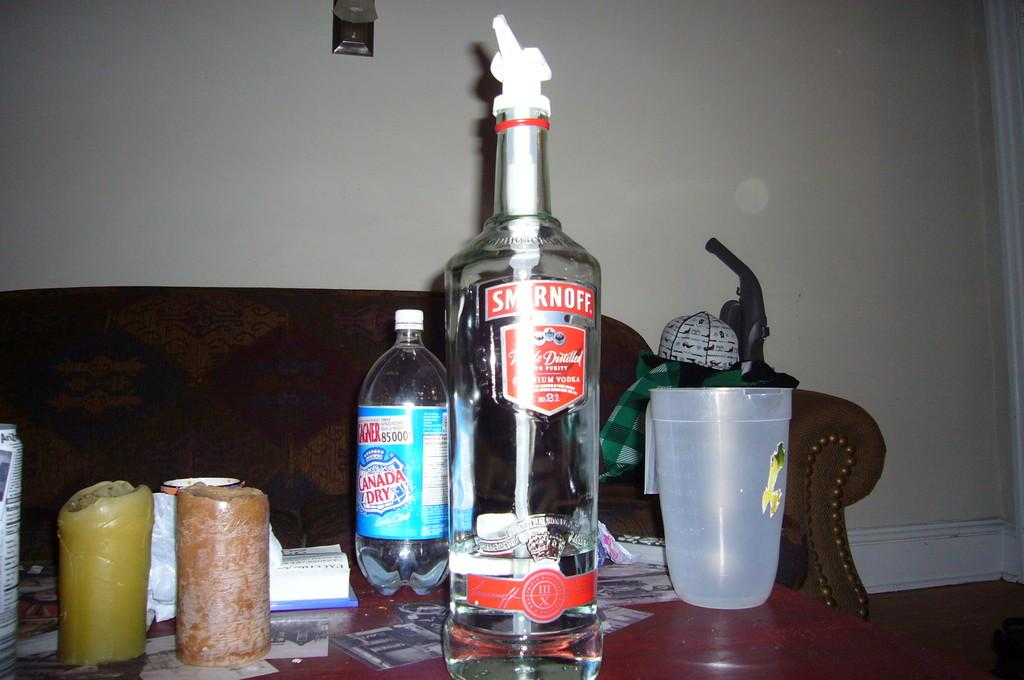<image>
Write a terse but informative summary of the picture. a coffee table with candles and bottles of Smirnoff and Canada Dry 